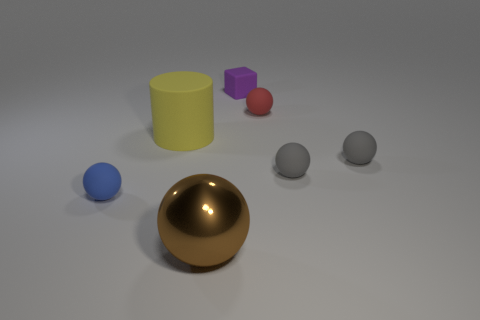Add 3 tiny red balls. How many objects exist? 10 Subtract all blue balls. How many balls are left? 4 Subtract all cyan cylinders. How many gray spheres are left? 2 Subtract all gray spheres. How many spheres are left? 3 Subtract all blocks. How many objects are left? 6 Subtract all blue balls. Subtract all cyan cylinders. How many balls are left? 4 Subtract all small gray rubber objects. Subtract all brown metallic balls. How many objects are left? 4 Add 5 yellow objects. How many yellow objects are left? 6 Add 3 tiny brown cubes. How many tiny brown cubes exist? 3 Subtract 0 cyan balls. How many objects are left? 7 